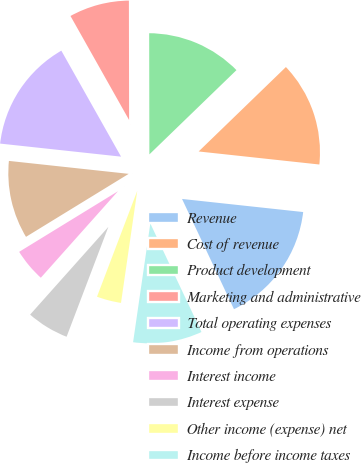Convert chart. <chart><loc_0><loc_0><loc_500><loc_500><pie_chart><fcel>Revenue<fcel>Cost of revenue<fcel>Product development<fcel>Marketing and administrative<fcel>Total operating expenses<fcel>Income from operations<fcel>Interest income<fcel>Interest expense<fcel>Other income (expense) net<fcel>Income before income taxes<nl><fcel>16.28%<fcel>13.95%<fcel>12.79%<fcel>8.14%<fcel>15.12%<fcel>10.47%<fcel>4.65%<fcel>5.81%<fcel>3.49%<fcel>9.3%<nl></chart> 